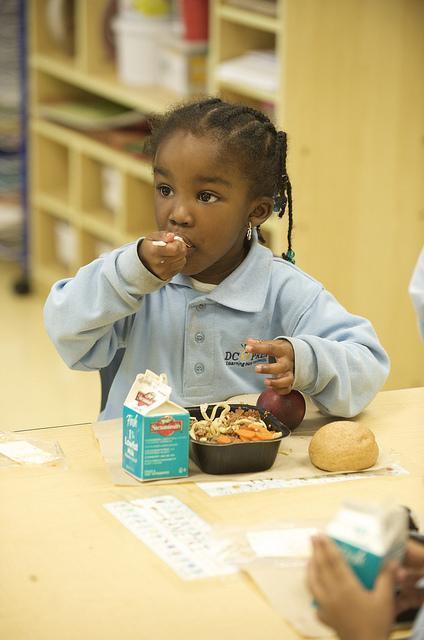How many different drinks are there?
Give a very brief answer. 1. How many people can you see?
Give a very brief answer. 2. 